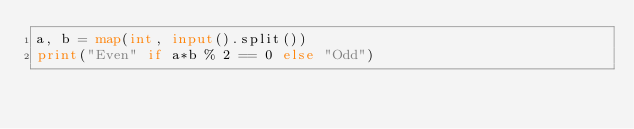Convert code to text. <code><loc_0><loc_0><loc_500><loc_500><_Python_>a, b = map(int, input().split())
print("Even" if a*b % 2 == 0 else "Odd")</code> 